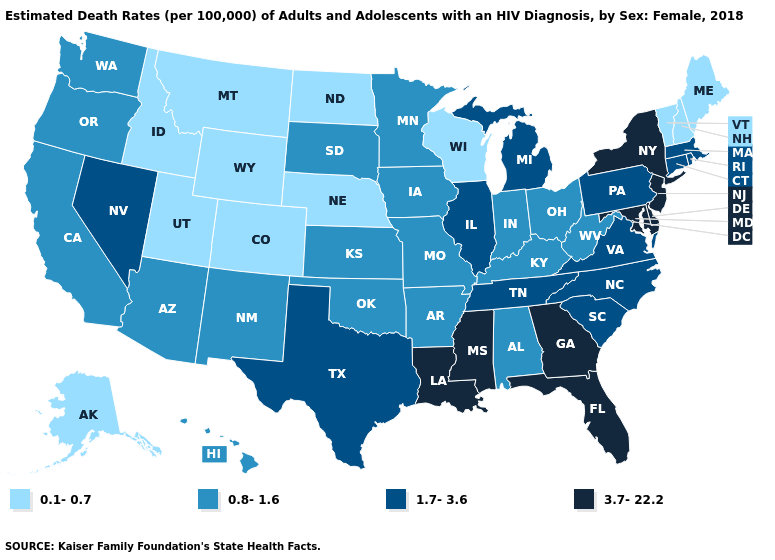What is the lowest value in states that border Washington?
Concise answer only. 0.1-0.7. Which states have the highest value in the USA?
Give a very brief answer. Delaware, Florida, Georgia, Louisiana, Maryland, Mississippi, New Jersey, New York. Does Kentucky have the same value as New Jersey?
Give a very brief answer. No. Name the states that have a value in the range 1.7-3.6?
Keep it brief. Connecticut, Illinois, Massachusetts, Michigan, Nevada, North Carolina, Pennsylvania, Rhode Island, South Carolina, Tennessee, Texas, Virginia. Among the states that border Nebraska , does Colorado have the lowest value?
Concise answer only. Yes. Name the states that have a value in the range 1.7-3.6?
Short answer required. Connecticut, Illinois, Massachusetts, Michigan, Nevada, North Carolina, Pennsylvania, Rhode Island, South Carolina, Tennessee, Texas, Virginia. Name the states that have a value in the range 1.7-3.6?
Concise answer only. Connecticut, Illinois, Massachusetts, Michigan, Nevada, North Carolina, Pennsylvania, Rhode Island, South Carolina, Tennessee, Texas, Virginia. Among the states that border New Jersey , which have the highest value?
Give a very brief answer. Delaware, New York. What is the highest value in states that border Wisconsin?
Quick response, please. 1.7-3.6. What is the value of Delaware?
Write a very short answer. 3.7-22.2. What is the highest value in the USA?
Be succinct. 3.7-22.2. Name the states that have a value in the range 3.7-22.2?
Concise answer only. Delaware, Florida, Georgia, Louisiana, Maryland, Mississippi, New Jersey, New York. What is the value of Nebraska?
Answer briefly. 0.1-0.7. Name the states that have a value in the range 0.8-1.6?
Be succinct. Alabama, Arizona, Arkansas, California, Hawaii, Indiana, Iowa, Kansas, Kentucky, Minnesota, Missouri, New Mexico, Ohio, Oklahoma, Oregon, South Dakota, Washington, West Virginia. Name the states that have a value in the range 1.7-3.6?
Write a very short answer. Connecticut, Illinois, Massachusetts, Michigan, Nevada, North Carolina, Pennsylvania, Rhode Island, South Carolina, Tennessee, Texas, Virginia. 